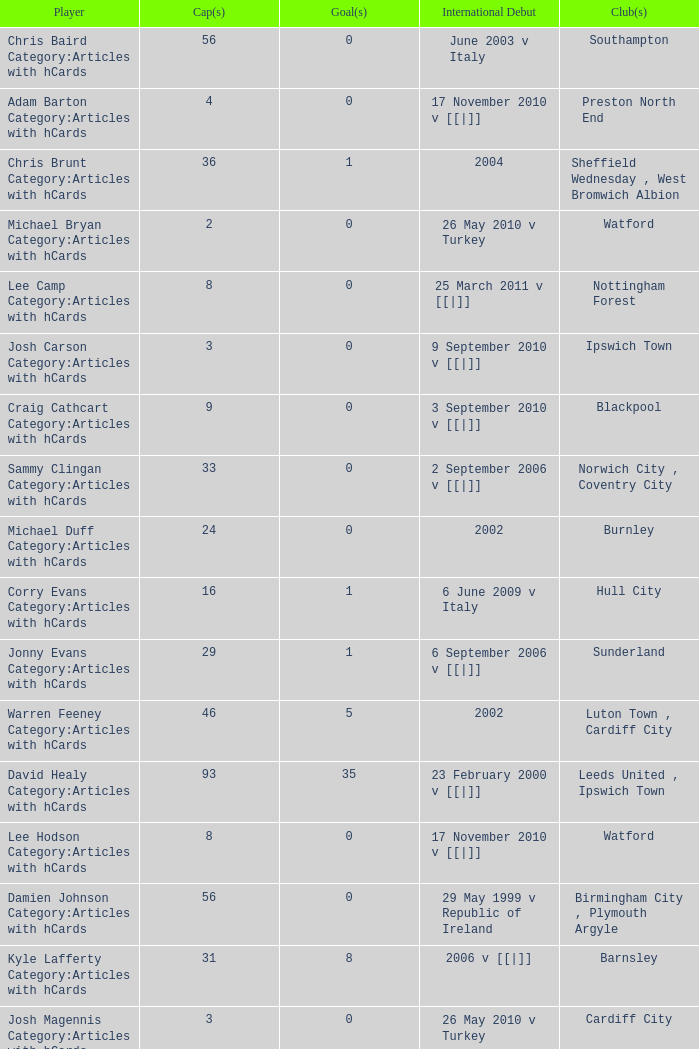How many players had 8 goals? 1.0. 